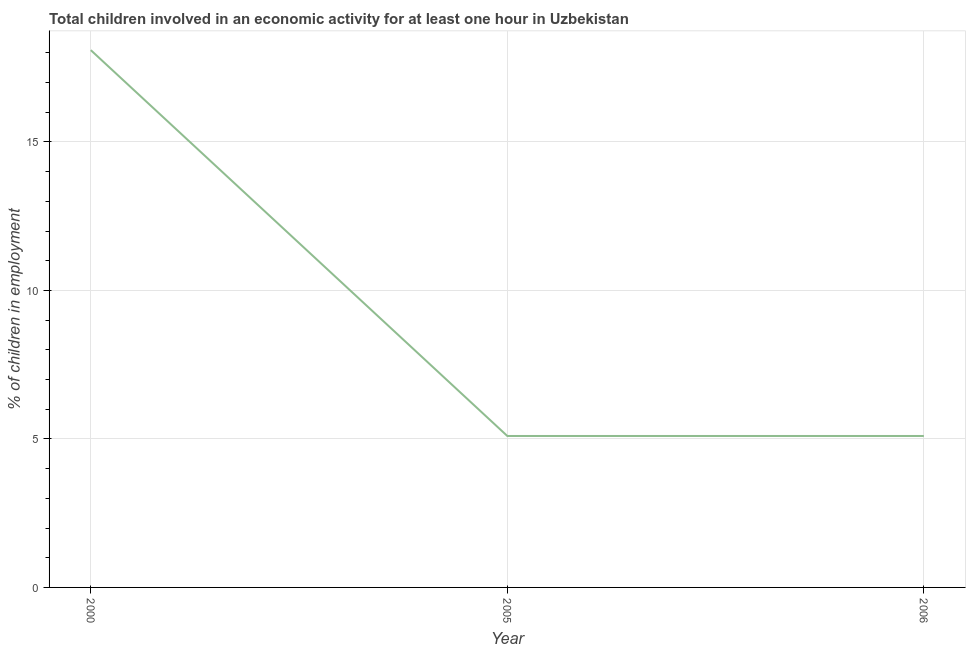What is the percentage of children in employment in 2005?
Ensure brevity in your answer.  5.1. Across all years, what is the maximum percentage of children in employment?
Make the answer very short. 18.09. Across all years, what is the minimum percentage of children in employment?
Your answer should be very brief. 5.1. In which year was the percentage of children in employment minimum?
Give a very brief answer. 2005. What is the sum of the percentage of children in employment?
Give a very brief answer. 28.29. What is the difference between the percentage of children in employment in 2000 and 2005?
Your response must be concise. 12.99. What is the average percentage of children in employment per year?
Ensure brevity in your answer.  9.43. Do a majority of the years between 2000 and 2005 (inclusive) have percentage of children in employment greater than 15 %?
Provide a short and direct response. No. What is the ratio of the percentage of children in employment in 2005 to that in 2006?
Your response must be concise. 1. Is the difference between the percentage of children in employment in 2005 and 2006 greater than the difference between any two years?
Make the answer very short. No. What is the difference between the highest and the second highest percentage of children in employment?
Keep it short and to the point. 12.99. What is the difference between the highest and the lowest percentage of children in employment?
Make the answer very short. 12.99. How many lines are there?
Your response must be concise. 1. How many years are there in the graph?
Your answer should be compact. 3. What is the difference between two consecutive major ticks on the Y-axis?
Give a very brief answer. 5. Does the graph contain grids?
Provide a short and direct response. Yes. What is the title of the graph?
Your response must be concise. Total children involved in an economic activity for at least one hour in Uzbekistan. What is the label or title of the X-axis?
Provide a succinct answer. Year. What is the label or title of the Y-axis?
Provide a short and direct response. % of children in employment. What is the % of children in employment of 2000?
Your response must be concise. 18.09. What is the difference between the % of children in employment in 2000 and 2005?
Give a very brief answer. 12.99. What is the difference between the % of children in employment in 2000 and 2006?
Offer a very short reply. 12.99. What is the difference between the % of children in employment in 2005 and 2006?
Provide a succinct answer. 0. What is the ratio of the % of children in employment in 2000 to that in 2005?
Give a very brief answer. 3.55. What is the ratio of the % of children in employment in 2000 to that in 2006?
Provide a short and direct response. 3.55. What is the ratio of the % of children in employment in 2005 to that in 2006?
Ensure brevity in your answer.  1. 